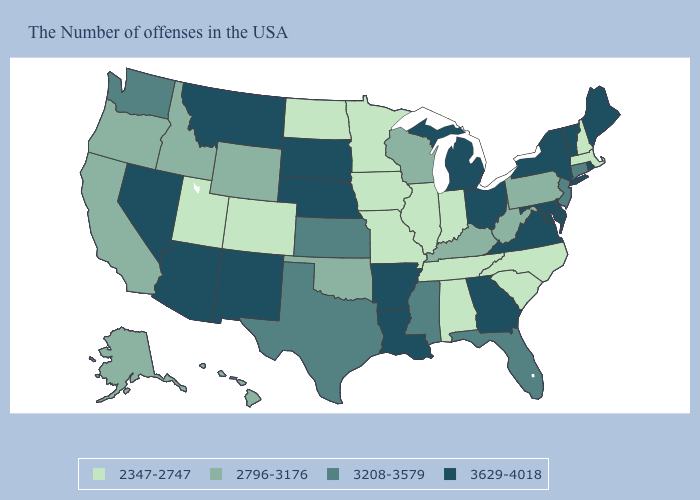Name the states that have a value in the range 3629-4018?
Short answer required. Maine, Rhode Island, Vermont, New York, Delaware, Maryland, Virginia, Ohio, Georgia, Michigan, Louisiana, Arkansas, Nebraska, South Dakota, New Mexico, Montana, Arizona, Nevada. Does Delaware have the highest value in the USA?
Be succinct. Yes. Name the states that have a value in the range 2796-3176?
Be succinct. Pennsylvania, West Virginia, Kentucky, Wisconsin, Oklahoma, Wyoming, Idaho, California, Oregon, Alaska, Hawaii. Which states have the lowest value in the USA?
Concise answer only. Massachusetts, New Hampshire, North Carolina, South Carolina, Indiana, Alabama, Tennessee, Illinois, Missouri, Minnesota, Iowa, North Dakota, Colorado, Utah. Does the map have missing data?
Write a very short answer. No. What is the value of Kentucky?
Keep it brief. 2796-3176. How many symbols are there in the legend?
Answer briefly. 4. What is the value of Virginia?
Be succinct. 3629-4018. Which states have the lowest value in the USA?
Give a very brief answer. Massachusetts, New Hampshire, North Carolina, South Carolina, Indiana, Alabama, Tennessee, Illinois, Missouri, Minnesota, Iowa, North Dakota, Colorado, Utah. Name the states that have a value in the range 2796-3176?
Answer briefly. Pennsylvania, West Virginia, Kentucky, Wisconsin, Oklahoma, Wyoming, Idaho, California, Oregon, Alaska, Hawaii. What is the highest value in the USA?
Keep it brief. 3629-4018. What is the lowest value in the MidWest?
Short answer required. 2347-2747. Name the states that have a value in the range 2796-3176?
Concise answer only. Pennsylvania, West Virginia, Kentucky, Wisconsin, Oklahoma, Wyoming, Idaho, California, Oregon, Alaska, Hawaii. What is the highest value in the MidWest ?
Give a very brief answer. 3629-4018. 